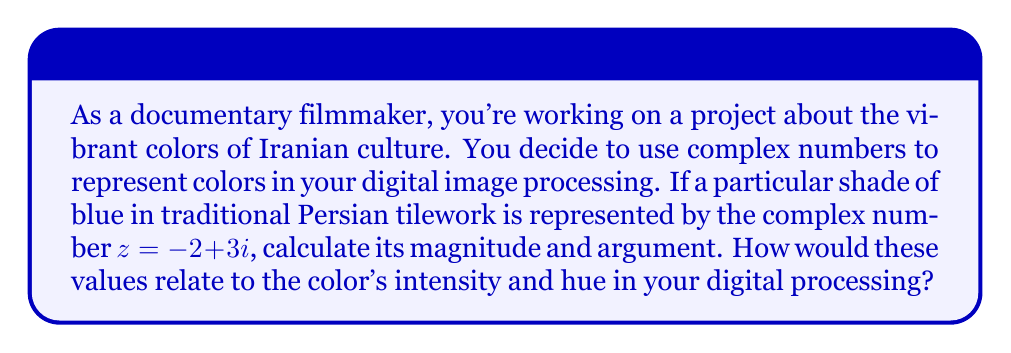Teach me how to tackle this problem. To solve this problem, we need to calculate the magnitude and argument of the given complex number $z = -2 + 3i$.

1. Magnitude calculation:
   The magnitude of a complex number $z = a + bi$ is given by the formula:
   $$|z| = \sqrt{a^2 + b^2}$$
   
   For our complex number:
   $$|z| = \sqrt{(-2)^2 + 3^2} = \sqrt{4 + 9} = \sqrt{13}$$

2. Argument calculation:
   The argument of a complex number is the angle it makes with the positive real axis, calculated using the arctangent function:
   $$\arg(z) = \tan^{-1}\left(\frac{b}{a}\right)$$
   
   However, we need to be careful about the quadrant. Since our complex number is in the second quadrant (negative real part, positive imaginary part), we need to add $\pi$ to the result:
   
   $$\arg(z) = \tan^{-1}\left(\frac{3}{-2}\right) + \pi = -\tan^{-1}\left(\frac{3}{2}\right) + \pi$$

In digital image processing:
- The magnitude $|z|$ relates to the intensity or brightness of the color. A larger magnitude would represent a more vivid or brighter color.
- The argument $\arg(z)$ relates to the hue of the color. Different arguments correspond to different color hues on the color wheel.

This representation allows for efficient manipulation of color information in digital image processing, which can be particularly useful when working with the rich and diverse colors found in Iranian art and architecture.
Answer: Magnitude: $|z| = \sqrt{13}$
Argument: $\arg(z) = -\tan^{-1}\left(\frac{3}{2}\right) + \pi$ radians 